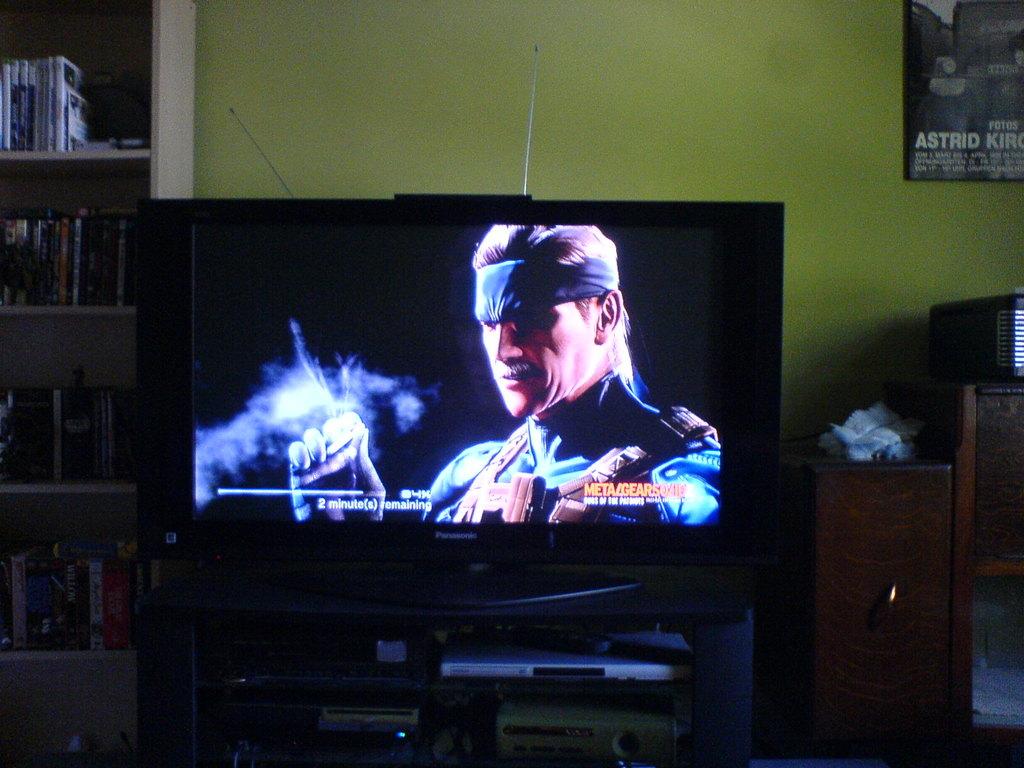How many minutes are remaining?
Ensure brevity in your answer.  2. What name is on the poster?
Offer a very short reply. Astrid. 